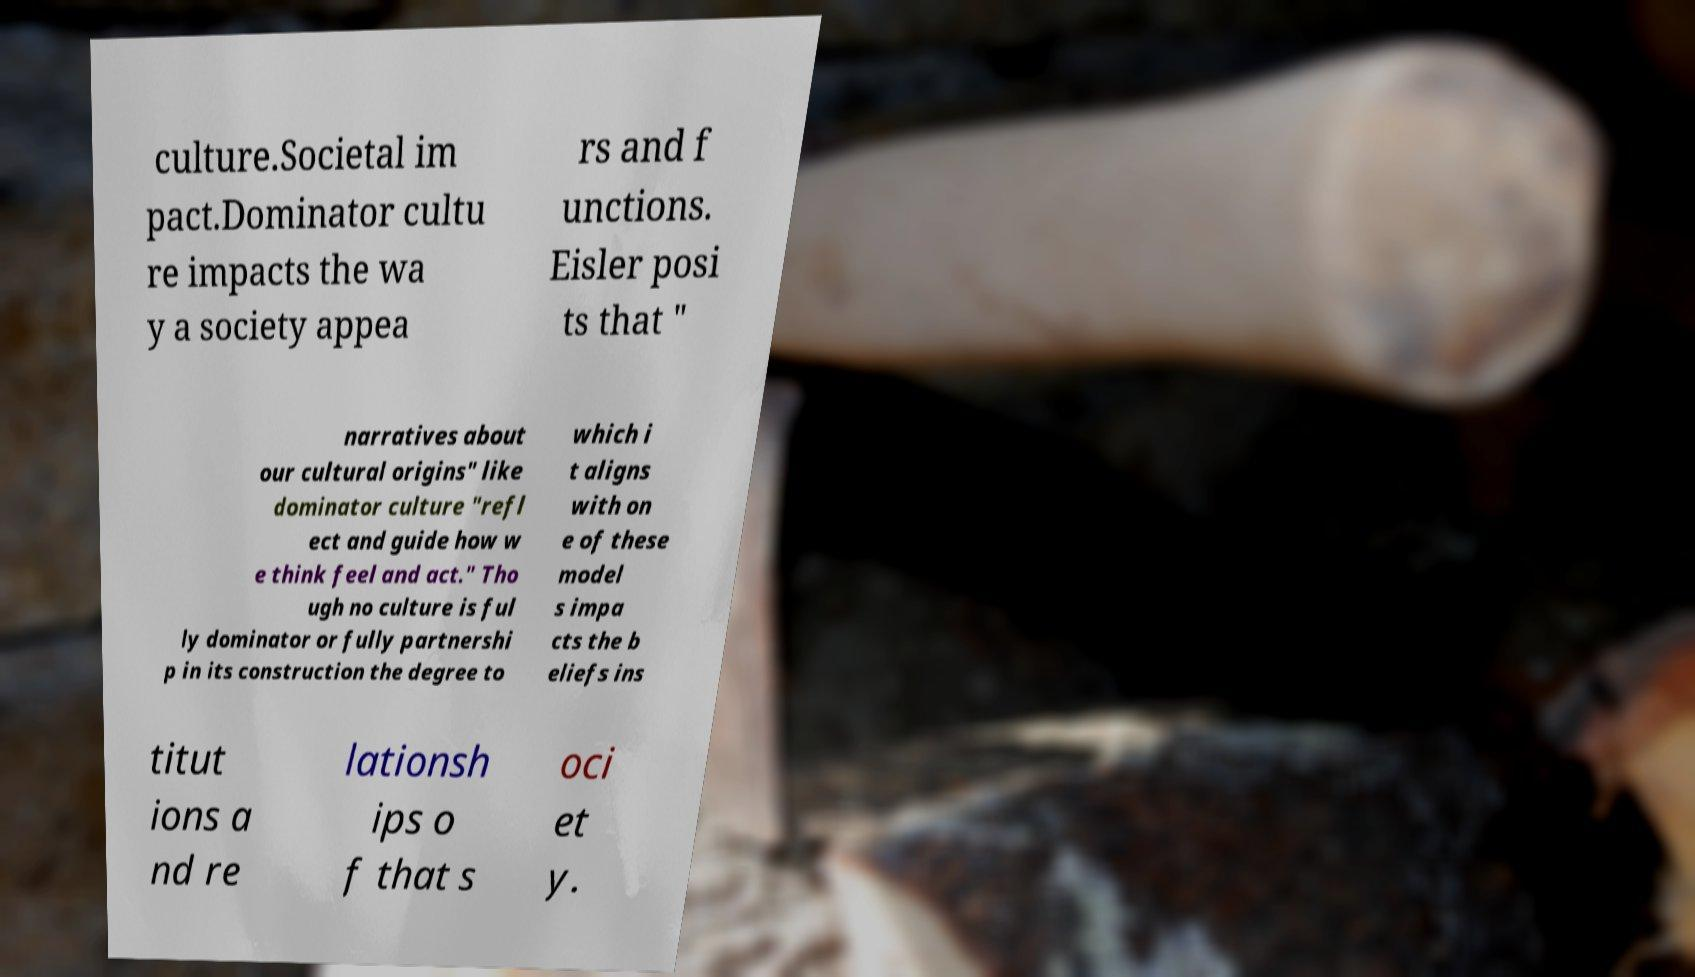For documentation purposes, I need the text within this image transcribed. Could you provide that? culture.Societal im pact.Dominator cultu re impacts the wa y a society appea rs and f unctions. Eisler posi ts that " narratives about our cultural origins" like dominator culture "refl ect and guide how w e think feel and act." Tho ugh no culture is ful ly dominator or fully partnershi p in its construction the degree to which i t aligns with on e of these model s impa cts the b eliefs ins titut ions a nd re lationsh ips o f that s oci et y. 